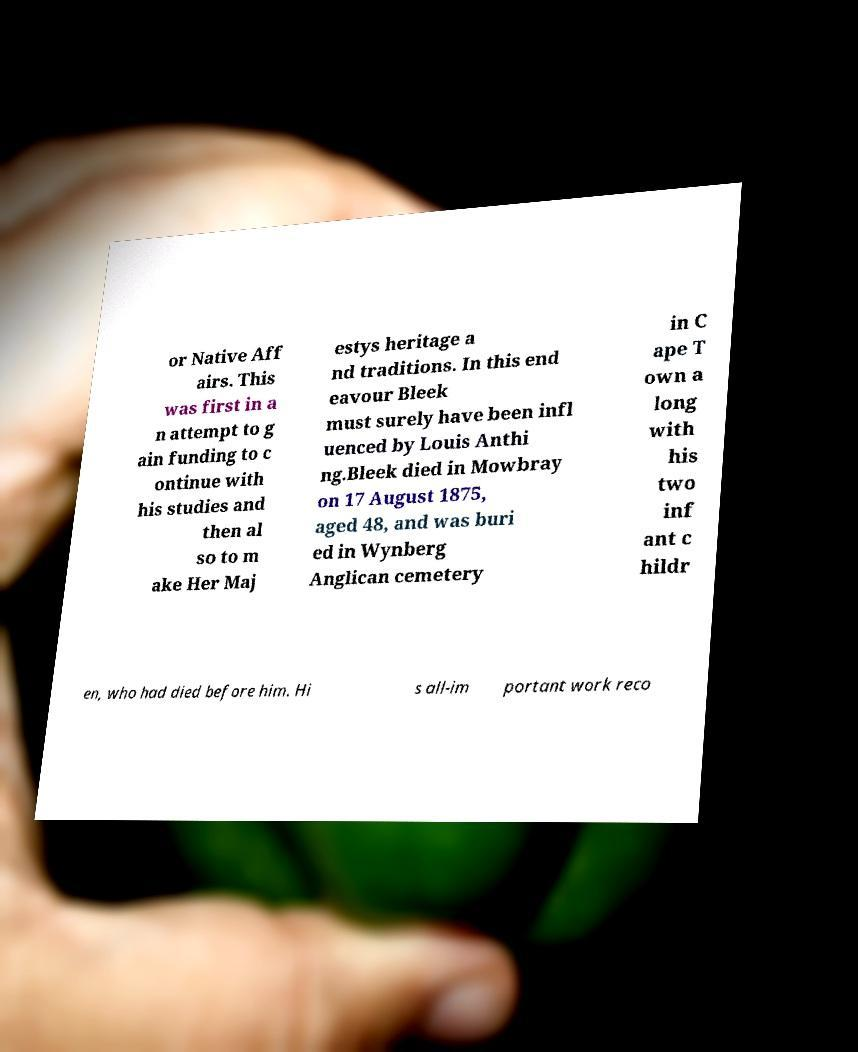Can you accurately transcribe the text from the provided image for me? or Native Aff airs. This was first in a n attempt to g ain funding to c ontinue with his studies and then al so to m ake Her Maj estys heritage a nd traditions. In this end eavour Bleek must surely have been infl uenced by Louis Anthi ng.Bleek died in Mowbray on 17 August 1875, aged 48, and was buri ed in Wynberg Anglican cemetery in C ape T own a long with his two inf ant c hildr en, who had died before him. Hi s all-im portant work reco 